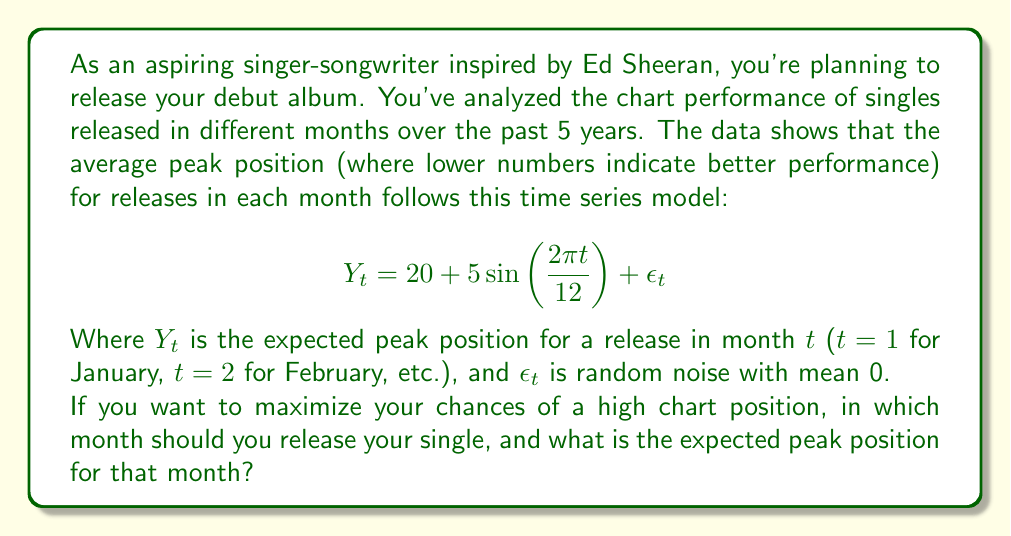What is the answer to this math problem? To solve this problem, we need to find the minimum value of $Y_t$ over the course of a year, as lower numbers indicate better chart performance. Let's approach this step-by-step:

1) The function $Y_t = 20 + 5\sin(\frac{2\pi t}{12}) + \epsilon_t$ represents a sinusoidal pattern with:
   - A mean of 20
   - An amplitude of 5
   - A period of 12 months

2) To find the minimum value, we need to find where $\sin(\frac{2\pi t}{12})$ is at its minimum, which is -1.

3) The sine function reaches its minimum value of -1 when its argument is $\frac{3\pi}{2}$ or $\frac{3\pi}{2} + 2\pi n$ where n is any integer.

4) So, we need to solve:
   $$\frac{2\pi t}{12} = \frac{3\pi}{2} + 2\pi n$$

5) Simplifying:
   $$t = 9 + 12n$$

6) The smallest positive integer solution for t is when n = 0, giving us t = 9.

7) This corresponds to September (the 9th month).

8) The expected peak position for a September release would be:
   $$Y_9 = 20 + 5\sin(\frac{2\pi 9}{12}) + \epsilon_9$$
   $$= 20 + 5(-1) + 0 = 15$$

Note: We use 0 for $\epsilon_9$ as it represents random noise with a mean of 0.
Answer: You should release your single in September (t = 9), with an expected peak chart position of 15. 